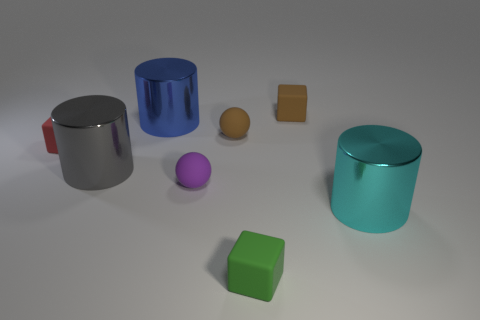How many things are either large things right of the large blue metal thing or small red matte objects?
Keep it short and to the point. 2. There is a matte block right of the cube that is in front of the cylinder on the right side of the small green thing; what color is it?
Your response must be concise. Brown. There is another tiny ball that is made of the same material as the small purple sphere; what color is it?
Offer a very short reply. Brown. What number of gray cylinders are the same material as the big blue object?
Provide a succinct answer. 1. Is the size of the metal cylinder that is to the right of the green matte cube the same as the blue thing?
Your answer should be very brief. Yes. There is a sphere that is the same size as the purple object; what is its color?
Your answer should be very brief. Brown. There is a gray cylinder; how many large gray metal cylinders are in front of it?
Make the answer very short. 0. Are there any brown matte cubes?
Give a very brief answer. Yes. How big is the matte object that is behind the tiny brown object that is on the left side of the rubber object behind the large blue metallic object?
Your answer should be compact. Small. What number of other things are the same size as the brown cube?
Your answer should be very brief. 4. 